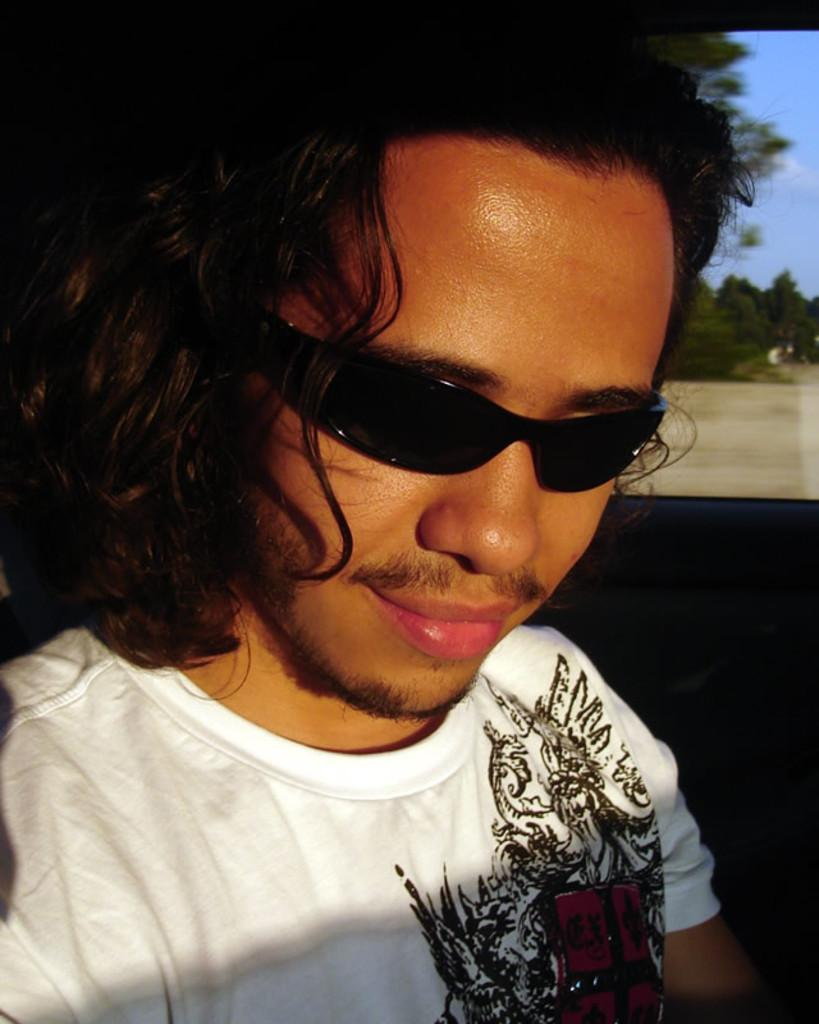Who is present in the image? There is a man in the image. What is the man doing in the image? The man is smiling in the image. What accessory is the man wearing? The man is wearing glasses in the image. What can be seen in the background of the image? There are trees and the sky visible in the background of the image. What type of yam is the man holding in the image? There is no yam present in the image; the man is not holding any object. 